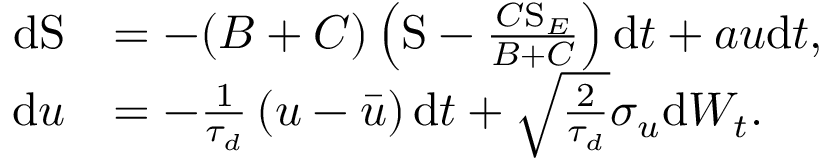<formula> <loc_0><loc_0><loc_500><loc_500>\begin{array} { r l } { d S } & { = - ( B + C ) \left ( S - \frac { C S _ { E } } { B + C } \right ) d t + a u d t , } \\ { d u } & { = - \frac { 1 } { \tau _ { d } } \left ( u - \bar { u } \right ) d t + \sqrt { \frac { 2 } { \tau _ { d } } } \sigma _ { u } d W _ { t } . } \end{array}</formula> 